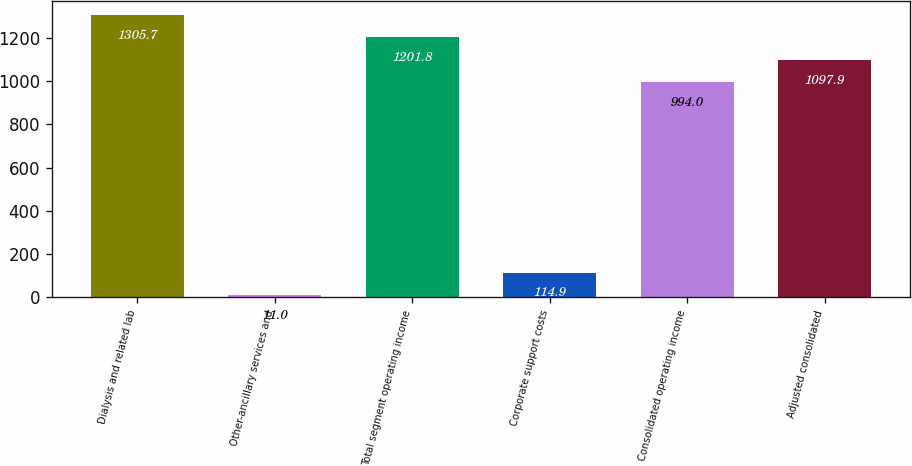<chart> <loc_0><loc_0><loc_500><loc_500><bar_chart><fcel>Dialysis and related lab<fcel>Other-ancillary services and<fcel>Total segment operating income<fcel>Corporate support costs<fcel>Consolidated operating income<fcel>Adjusted consolidated<nl><fcel>1305.7<fcel>11<fcel>1201.8<fcel>114.9<fcel>994<fcel>1097.9<nl></chart> 